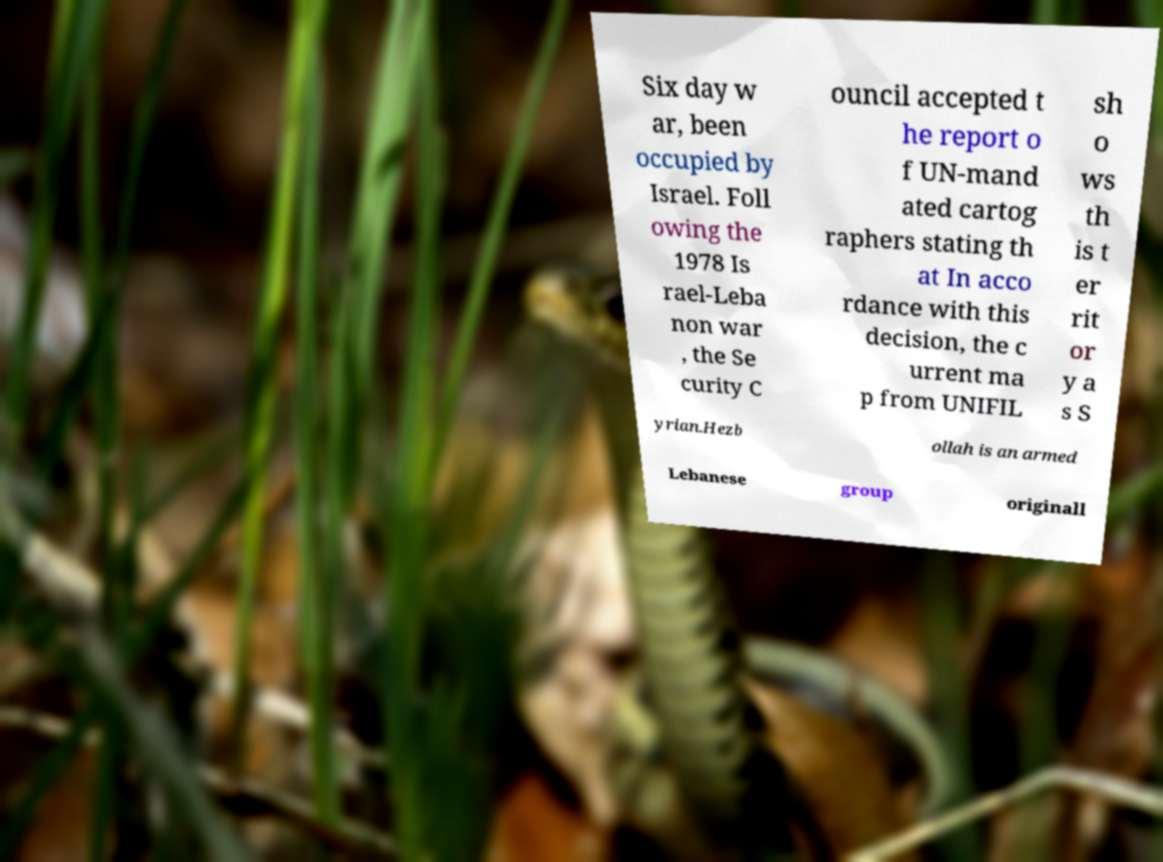Can you read and provide the text displayed in the image?This photo seems to have some interesting text. Can you extract and type it out for me? Six day w ar, been occupied by Israel. Foll owing the 1978 Is rael-Leba non war , the Se curity C ouncil accepted t he report o f UN-mand ated cartog raphers stating th at In acco rdance with this decision, the c urrent ma p from UNIFIL sh o ws th is t er rit or y a s S yrian.Hezb ollah is an armed Lebanese group originall 